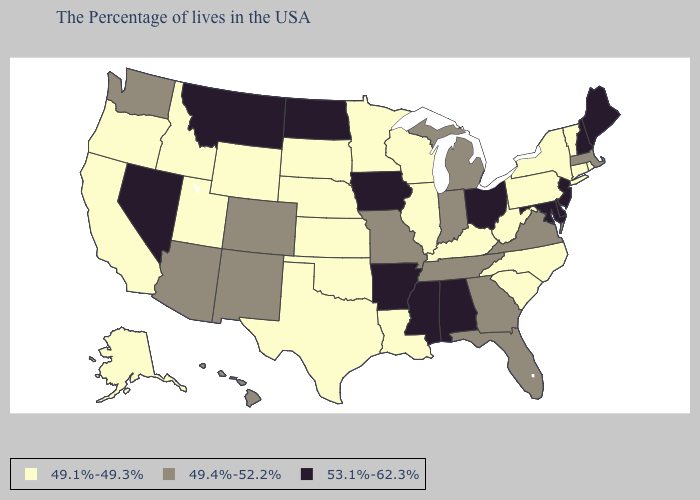Among the states that border Illinois , which have the lowest value?
Concise answer only. Kentucky, Wisconsin. Among the states that border Maryland , which have the lowest value?
Concise answer only. Pennsylvania, West Virginia. Which states have the highest value in the USA?
Quick response, please. Maine, New Hampshire, New Jersey, Delaware, Maryland, Ohio, Alabama, Mississippi, Arkansas, Iowa, North Dakota, Montana, Nevada. What is the value of Idaho?
Keep it brief. 49.1%-49.3%. What is the highest value in states that border Oklahoma?
Keep it brief. 53.1%-62.3%. Name the states that have a value in the range 49.1%-49.3%?
Keep it brief. Rhode Island, Vermont, Connecticut, New York, Pennsylvania, North Carolina, South Carolina, West Virginia, Kentucky, Wisconsin, Illinois, Louisiana, Minnesota, Kansas, Nebraska, Oklahoma, Texas, South Dakota, Wyoming, Utah, Idaho, California, Oregon, Alaska. Name the states that have a value in the range 49.1%-49.3%?
Quick response, please. Rhode Island, Vermont, Connecticut, New York, Pennsylvania, North Carolina, South Carolina, West Virginia, Kentucky, Wisconsin, Illinois, Louisiana, Minnesota, Kansas, Nebraska, Oklahoma, Texas, South Dakota, Wyoming, Utah, Idaho, California, Oregon, Alaska. What is the value of Vermont?
Write a very short answer. 49.1%-49.3%. Is the legend a continuous bar?
Keep it brief. No. What is the value of Connecticut?
Short answer required. 49.1%-49.3%. Does Iowa have the same value as Montana?
Concise answer only. Yes. Name the states that have a value in the range 49.1%-49.3%?
Be succinct. Rhode Island, Vermont, Connecticut, New York, Pennsylvania, North Carolina, South Carolina, West Virginia, Kentucky, Wisconsin, Illinois, Louisiana, Minnesota, Kansas, Nebraska, Oklahoma, Texas, South Dakota, Wyoming, Utah, Idaho, California, Oregon, Alaska. Does the first symbol in the legend represent the smallest category?
Write a very short answer. Yes. Does the map have missing data?
Answer briefly. No. Does the first symbol in the legend represent the smallest category?
Concise answer only. Yes. 